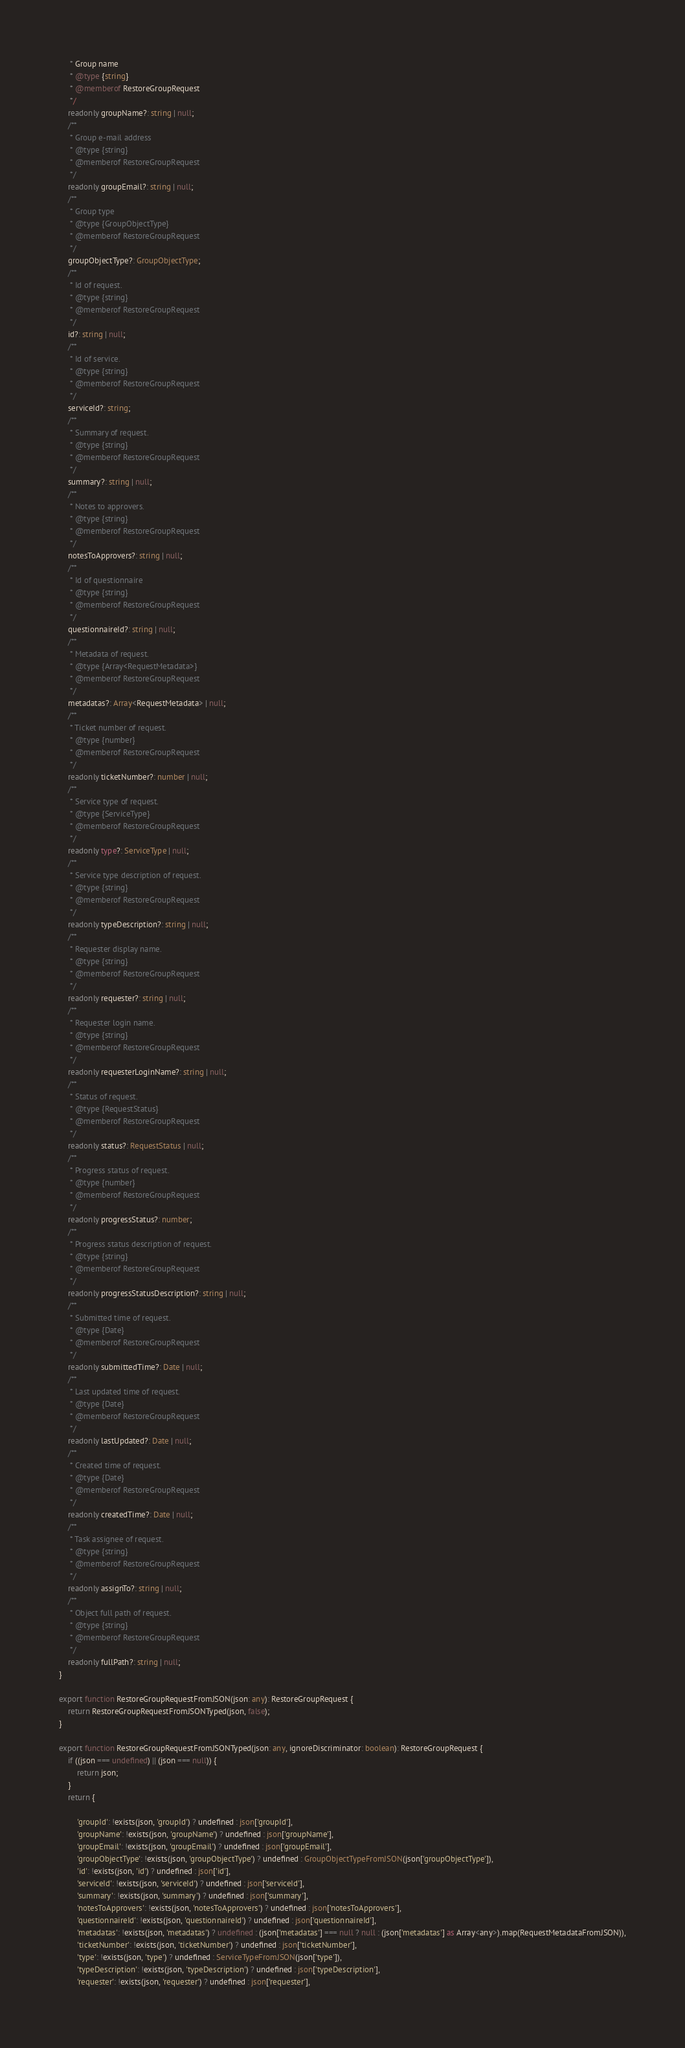Convert code to text. <code><loc_0><loc_0><loc_500><loc_500><_TypeScript_>     * Group name
     * @type {string}
     * @memberof RestoreGroupRequest
     */
    readonly groupName?: string | null;
    /**
     * Group e-mail address
     * @type {string}
     * @memberof RestoreGroupRequest
     */
    readonly groupEmail?: string | null;
    /**
     * Group type
     * @type {GroupObjectType}
     * @memberof RestoreGroupRequest
     */
    groupObjectType?: GroupObjectType;
    /**
     * Id of request.
     * @type {string}
     * @memberof RestoreGroupRequest
     */
    id?: string | null;
    /**
     * Id of service.
     * @type {string}
     * @memberof RestoreGroupRequest
     */
    serviceId?: string;
    /**
     * Summary of request.
     * @type {string}
     * @memberof RestoreGroupRequest
     */
    summary?: string | null;
    /**
     * Notes to approvers.
     * @type {string}
     * @memberof RestoreGroupRequest
     */
    notesToApprovers?: string | null;
    /**
     * Id of questionnaire
     * @type {string}
     * @memberof RestoreGroupRequest
     */
    questionnaireId?: string | null;
    /**
     * Metadata of request.
     * @type {Array<RequestMetadata>}
     * @memberof RestoreGroupRequest
     */
    metadatas?: Array<RequestMetadata> | null;
    /**
     * Ticket number of request.
     * @type {number}
     * @memberof RestoreGroupRequest
     */
    readonly ticketNumber?: number | null;
    /**
     * Service type of request.
     * @type {ServiceType}
     * @memberof RestoreGroupRequest
     */
    readonly type?: ServiceType | null;
    /**
     * Service type description of request.
     * @type {string}
     * @memberof RestoreGroupRequest
     */
    readonly typeDescription?: string | null;
    /**
     * Requester display name.
     * @type {string}
     * @memberof RestoreGroupRequest
     */
    readonly requester?: string | null;
    /**
     * Requester login name.
     * @type {string}
     * @memberof RestoreGroupRequest
     */
    readonly requesterLoginName?: string | null;
    /**
     * Status of request.
     * @type {RequestStatus}
     * @memberof RestoreGroupRequest
     */
    readonly status?: RequestStatus | null;
    /**
     * Progress status of request.
     * @type {number}
     * @memberof RestoreGroupRequest
     */
    readonly progressStatus?: number;
    /**
     * Progress status description of request.
     * @type {string}
     * @memberof RestoreGroupRequest
     */
    readonly progressStatusDescription?: string | null;
    /**
     * Submitted time of request.
     * @type {Date}
     * @memberof RestoreGroupRequest
     */
    readonly submittedTime?: Date | null;
    /**
     * Last updated time of request.
     * @type {Date}
     * @memberof RestoreGroupRequest
     */
    readonly lastUpdated?: Date | null;
    /**
     * Created time of request.
     * @type {Date}
     * @memberof RestoreGroupRequest
     */
    readonly createdTime?: Date | null;
    /**
     * Task assignee of request.
     * @type {string}
     * @memberof RestoreGroupRequest
     */
    readonly assignTo?: string | null;
    /**
     * Object full path of request.
     * @type {string}
     * @memberof RestoreGroupRequest
     */
    readonly fullPath?: string | null;
}

export function RestoreGroupRequestFromJSON(json: any): RestoreGroupRequest {
    return RestoreGroupRequestFromJSONTyped(json, false);
}

export function RestoreGroupRequestFromJSONTyped(json: any, ignoreDiscriminator: boolean): RestoreGroupRequest {
    if ((json === undefined) || (json === null)) {
        return json;
    }
    return {
        
        'groupId': !exists(json, 'groupId') ? undefined : json['groupId'],
        'groupName': !exists(json, 'groupName') ? undefined : json['groupName'],
        'groupEmail': !exists(json, 'groupEmail') ? undefined : json['groupEmail'],
        'groupObjectType': !exists(json, 'groupObjectType') ? undefined : GroupObjectTypeFromJSON(json['groupObjectType']),
        'id': !exists(json, 'id') ? undefined : json['id'],
        'serviceId': !exists(json, 'serviceId') ? undefined : json['serviceId'],
        'summary': !exists(json, 'summary') ? undefined : json['summary'],
        'notesToApprovers': !exists(json, 'notesToApprovers') ? undefined : json['notesToApprovers'],
        'questionnaireId': !exists(json, 'questionnaireId') ? undefined : json['questionnaireId'],
        'metadatas': !exists(json, 'metadatas') ? undefined : (json['metadatas'] === null ? null : (json['metadatas'] as Array<any>).map(RequestMetadataFromJSON)),
        'ticketNumber': !exists(json, 'ticketNumber') ? undefined : json['ticketNumber'],
        'type': !exists(json, 'type') ? undefined : ServiceTypeFromJSON(json['type']),
        'typeDescription': !exists(json, 'typeDescription') ? undefined : json['typeDescription'],
        'requester': !exists(json, 'requester') ? undefined : json['requester'],</code> 